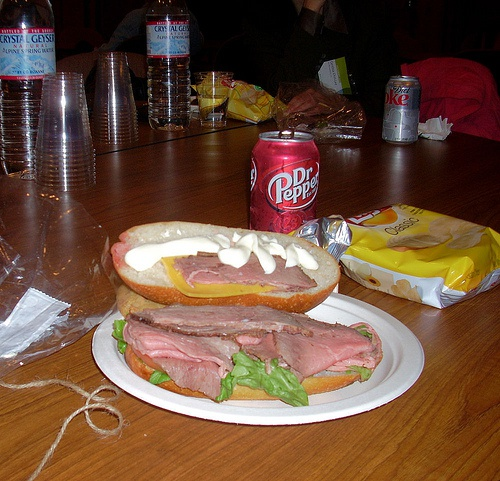Describe the objects in this image and their specific colors. I can see dining table in black, brown, maroon, and lightgray tones, sandwich in black, salmon, lightpink, tan, and white tones, bottle in black, gray, and maroon tones, cup in black, maroon, brown, and lightgray tones, and people in black and maroon tones in this image. 